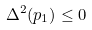Convert formula to latex. <formula><loc_0><loc_0><loc_500><loc_500>\Delta ^ { 2 } ( p _ { 1 } ) \leq 0</formula> 